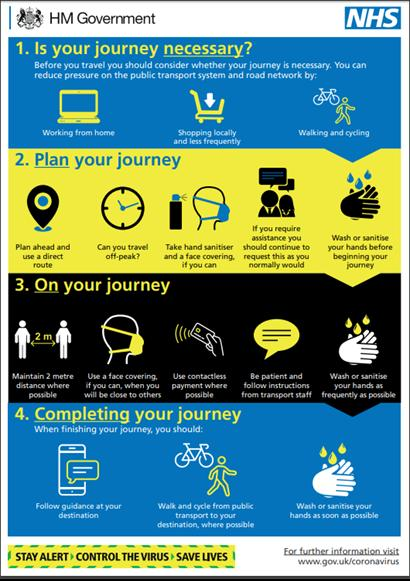Point out several critical features in this image. It is advisable to wash or sanitize your hands before embarking on your journey, as this will help to keep your hands clean and hygienic. It is recommended to maintain a distance of 2 meters from the train while it is in operation. Walking and cycling are alternate modes of travel that can be used instead of public transport. It is crucial to wash or sanitise your hands frequently, especially when travelling, to prevent the spread of harmful bacteria and diseases. Contactless payment is considered to be the most preferable method of payment. 